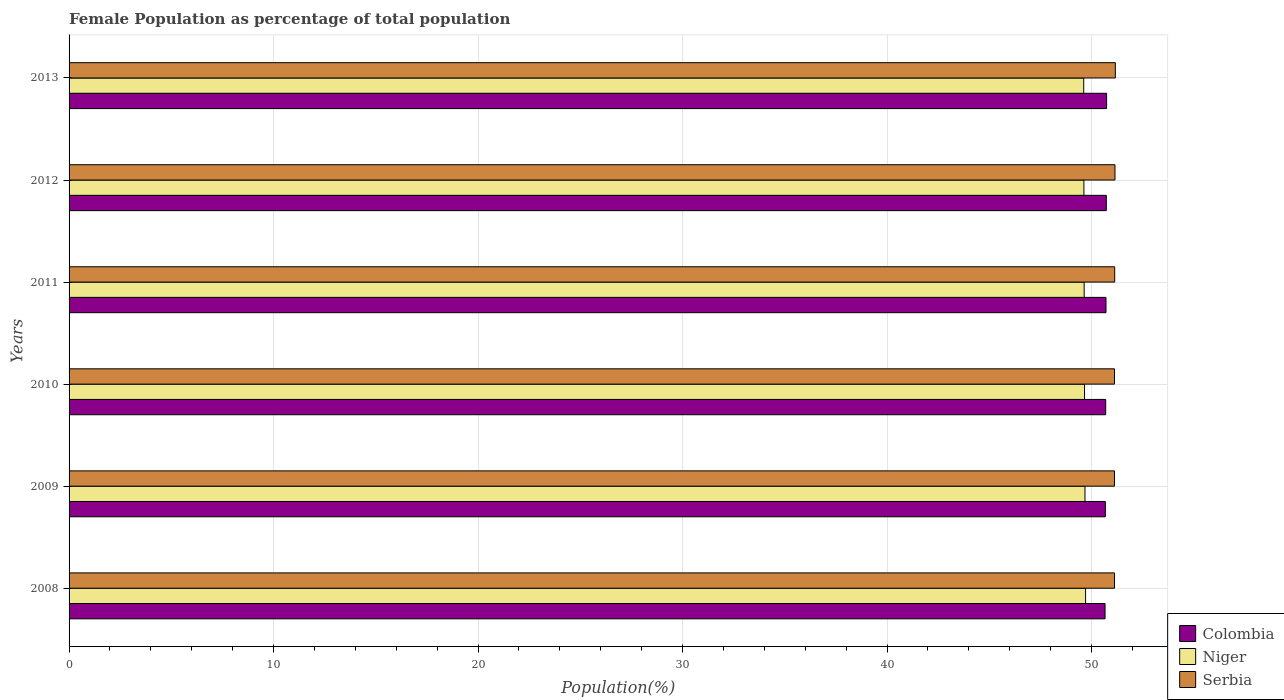How many different coloured bars are there?
Keep it short and to the point. 3. Are the number of bars on each tick of the Y-axis equal?
Your answer should be compact. Yes. How many bars are there on the 5th tick from the bottom?
Offer a terse response. 3. What is the label of the 5th group of bars from the top?
Your answer should be compact. 2009. In how many cases, is the number of bars for a given year not equal to the number of legend labels?
Offer a very short reply. 0. What is the female population in in Colombia in 2008?
Make the answer very short. 50.66. Across all years, what is the maximum female population in in Colombia?
Your response must be concise. 50.74. Across all years, what is the minimum female population in in Serbia?
Offer a very short reply. 51.12. What is the total female population in in Niger in the graph?
Provide a succinct answer. 297.94. What is the difference between the female population in in Colombia in 2008 and that in 2012?
Your answer should be compact. -0.06. What is the difference between the female population in in Niger in 2008 and the female population in in Serbia in 2012?
Make the answer very short. -1.44. What is the average female population in in Colombia per year?
Your answer should be compact. 50.7. In the year 2011, what is the difference between the female population in in Serbia and female population in in Colombia?
Your response must be concise. 0.42. What is the ratio of the female population in in Serbia in 2010 to that in 2013?
Your answer should be compact. 1. Is the female population in in Serbia in 2009 less than that in 2013?
Your answer should be compact. Yes. What is the difference between the highest and the second highest female population in in Colombia?
Provide a succinct answer. 0.02. What is the difference between the highest and the lowest female population in in Niger?
Provide a succinct answer. 0.09. What does the 1st bar from the top in 2008 represents?
Your response must be concise. Serbia. How many bars are there?
Your answer should be compact. 18. What is the difference between two consecutive major ticks on the X-axis?
Give a very brief answer. 10. Are the values on the major ticks of X-axis written in scientific E-notation?
Provide a succinct answer. No. Does the graph contain any zero values?
Ensure brevity in your answer.  No. Does the graph contain grids?
Provide a short and direct response. Yes. How many legend labels are there?
Offer a terse response. 3. How are the legend labels stacked?
Your response must be concise. Vertical. What is the title of the graph?
Give a very brief answer. Female Population as percentage of total population. What is the label or title of the X-axis?
Your response must be concise. Population(%). What is the Population(%) in Colombia in 2008?
Give a very brief answer. 50.66. What is the Population(%) of Niger in 2008?
Give a very brief answer. 49.71. What is the Population(%) in Serbia in 2008?
Your response must be concise. 51.13. What is the Population(%) of Colombia in 2009?
Your answer should be very brief. 50.68. What is the Population(%) of Niger in 2009?
Ensure brevity in your answer.  49.68. What is the Population(%) in Serbia in 2009?
Give a very brief answer. 51.12. What is the Population(%) in Colombia in 2010?
Provide a short and direct response. 50.69. What is the Population(%) of Niger in 2010?
Give a very brief answer. 49.66. What is the Population(%) in Serbia in 2010?
Offer a very short reply. 51.12. What is the Population(%) in Colombia in 2011?
Provide a short and direct response. 50.71. What is the Population(%) of Niger in 2011?
Provide a short and direct response. 49.64. What is the Population(%) of Serbia in 2011?
Offer a very short reply. 51.13. What is the Population(%) in Colombia in 2012?
Your answer should be very brief. 50.72. What is the Population(%) of Niger in 2012?
Make the answer very short. 49.63. What is the Population(%) in Serbia in 2012?
Ensure brevity in your answer.  51.15. What is the Population(%) of Colombia in 2013?
Offer a very short reply. 50.74. What is the Population(%) of Niger in 2013?
Offer a terse response. 49.62. What is the Population(%) in Serbia in 2013?
Offer a terse response. 51.16. Across all years, what is the maximum Population(%) of Colombia?
Provide a succinct answer. 50.74. Across all years, what is the maximum Population(%) in Niger?
Your answer should be very brief. 49.71. Across all years, what is the maximum Population(%) in Serbia?
Your answer should be very brief. 51.16. Across all years, what is the minimum Population(%) in Colombia?
Your answer should be very brief. 50.66. Across all years, what is the minimum Population(%) of Niger?
Provide a short and direct response. 49.62. Across all years, what is the minimum Population(%) in Serbia?
Give a very brief answer. 51.12. What is the total Population(%) of Colombia in the graph?
Keep it short and to the point. 304.2. What is the total Population(%) of Niger in the graph?
Offer a terse response. 297.94. What is the total Population(%) in Serbia in the graph?
Ensure brevity in your answer.  306.82. What is the difference between the Population(%) of Colombia in 2008 and that in 2009?
Your answer should be compact. -0.02. What is the difference between the Population(%) in Niger in 2008 and that in 2009?
Your answer should be very brief. 0.03. What is the difference between the Population(%) of Serbia in 2008 and that in 2009?
Provide a succinct answer. 0. What is the difference between the Population(%) of Colombia in 2008 and that in 2010?
Make the answer very short. -0.03. What is the difference between the Population(%) in Niger in 2008 and that in 2010?
Make the answer very short. 0.05. What is the difference between the Population(%) of Serbia in 2008 and that in 2010?
Offer a very short reply. 0. What is the difference between the Population(%) of Colombia in 2008 and that in 2011?
Your answer should be very brief. -0.05. What is the difference between the Population(%) of Niger in 2008 and that in 2011?
Your answer should be compact. 0.07. What is the difference between the Population(%) in Serbia in 2008 and that in 2011?
Your answer should be compact. -0.01. What is the difference between the Population(%) of Colombia in 2008 and that in 2012?
Offer a terse response. -0.06. What is the difference between the Population(%) of Niger in 2008 and that in 2012?
Offer a terse response. 0.08. What is the difference between the Population(%) in Serbia in 2008 and that in 2012?
Keep it short and to the point. -0.02. What is the difference between the Population(%) in Colombia in 2008 and that in 2013?
Your answer should be very brief. -0.08. What is the difference between the Population(%) in Niger in 2008 and that in 2013?
Provide a succinct answer. 0.09. What is the difference between the Population(%) of Serbia in 2008 and that in 2013?
Provide a short and direct response. -0.04. What is the difference between the Population(%) of Colombia in 2009 and that in 2010?
Provide a short and direct response. -0.02. What is the difference between the Population(%) of Niger in 2009 and that in 2010?
Make the answer very short. 0.02. What is the difference between the Population(%) of Serbia in 2009 and that in 2010?
Provide a succinct answer. -0. What is the difference between the Population(%) of Colombia in 2009 and that in 2011?
Your answer should be compact. -0.03. What is the difference between the Population(%) in Niger in 2009 and that in 2011?
Make the answer very short. 0.04. What is the difference between the Population(%) of Serbia in 2009 and that in 2011?
Keep it short and to the point. -0.01. What is the difference between the Population(%) of Colombia in 2009 and that in 2012?
Your response must be concise. -0.05. What is the difference between the Population(%) of Niger in 2009 and that in 2012?
Provide a short and direct response. 0.05. What is the difference between the Population(%) of Serbia in 2009 and that in 2012?
Your answer should be very brief. -0.02. What is the difference between the Population(%) in Colombia in 2009 and that in 2013?
Your answer should be very brief. -0.06. What is the difference between the Population(%) of Niger in 2009 and that in 2013?
Offer a very short reply. 0.06. What is the difference between the Population(%) in Serbia in 2009 and that in 2013?
Offer a very short reply. -0.04. What is the difference between the Population(%) in Colombia in 2010 and that in 2011?
Provide a short and direct response. -0.02. What is the difference between the Population(%) of Niger in 2010 and that in 2011?
Your answer should be very brief. 0.02. What is the difference between the Population(%) in Serbia in 2010 and that in 2011?
Provide a short and direct response. -0.01. What is the difference between the Population(%) of Colombia in 2010 and that in 2012?
Your answer should be compact. -0.03. What is the difference between the Population(%) of Niger in 2010 and that in 2012?
Provide a short and direct response. 0.03. What is the difference between the Population(%) in Serbia in 2010 and that in 2012?
Offer a very short reply. -0.02. What is the difference between the Population(%) of Colombia in 2010 and that in 2013?
Make the answer very short. -0.05. What is the difference between the Population(%) in Niger in 2010 and that in 2013?
Keep it short and to the point. 0.04. What is the difference between the Population(%) in Serbia in 2010 and that in 2013?
Give a very brief answer. -0.04. What is the difference between the Population(%) in Colombia in 2011 and that in 2012?
Your response must be concise. -0.02. What is the difference between the Population(%) of Niger in 2011 and that in 2012?
Provide a short and direct response. 0.01. What is the difference between the Population(%) of Serbia in 2011 and that in 2012?
Ensure brevity in your answer.  -0.01. What is the difference between the Population(%) of Colombia in 2011 and that in 2013?
Your answer should be very brief. -0.03. What is the difference between the Population(%) of Niger in 2011 and that in 2013?
Offer a terse response. 0.02. What is the difference between the Population(%) of Serbia in 2011 and that in 2013?
Provide a short and direct response. -0.03. What is the difference between the Population(%) in Colombia in 2012 and that in 2013?
Keep it short and to the point. -0.02. What is the difference between the Population(%) in Niger in 2012 and that in 2013?
Give a very brief answer. 0.01. What is the difference between the Population(%) of Serbia in 2012 and that in 2013?
Your answer should be compact. -0.02. What is the difference between the Population(%) of Colombia in 2008 and the Population(%) of Niger in 2009?
Give a very brief answer. 0.98. What is the difference between the Population(%) of Colombia in 2008 and the Population(%) of Serbia in 2009?
Keep it short and to the point. -0.46. What is the difference between the Population(%) of Niger in 2008 and the Population(%) of Serbia in 2009?
Offer a very short reply. -1.41. What is the difference between the Population(%) in Colombia in 2008 and the Population(%) in Niger in 2010?
Offer a terse response. 1. What is the difference between the Population(%) of Colombia in 2008 and the Population(%) of Serbia in 2010?
Your answer should be very brief. -0.46. What is the difference between the Population(%) in Niger in 2008 and the Population(%) in Serbia in 2010?
Offer a very short reply. -1.41. What is the difference between the Population(%) of Colombia in 2008 and the Population(%) of Niger in 2011?
Your answer should be compact. 1.02. What is the difference between the Population(%) of Colombia in 2008 and the Population(%) of Serbia in 2011?
Provide a short and direct response. -0.47. What is the difference between the Population(%) in Niger in 2008 and the Population(%) in Serbia in 2011?
Keep it short and to the point. -1.42. What is the difference between the Population(%) of Colombia in 2008 and the Population(%) of Niger in 2012?
Offer a terse response. 1.03. What is the difference between the Population(%) of Colombia in 2008 and the Population(%) of Serbia in 2012?
Offer a very short reply. -0.49. What is the difference between the Population(%) of Niger in 2008 and the Population(%) of Serbia in 2012?
Provide a succinct answer. -1.44. What is the difference between the Population(%) of Colombia in 2008 and the Population(%) of Niger in 2013?
Ensure brevity in your answer.  1.04. What is the difference between the Population(%) in Colombia in 2008 and the Population(%) in Serbia in 2013?
Give a very brief answer. -0.5. What is the difference between the Population(%) of Niger in 2008 and the Population(%) of Serbia in 2013?
Provide a short and direct response. -1.46. What is the difference between the Population(%) in Colombia in 2009 and the Population(%) in Niger in 2010?
Provide a succinct answer. 1.02. What is the difference between the Population(%) in Colombia in 2009 and the Population(%) in Serbia in 2010?
Your answer should be compact. -0.45. What is the difference between the Population(%) in Niger in 2009 and the Population(%) in Serbia in 2010?
Offer a terse response. -1.44. What is the difference between the Population(%) in Colombia in 2009 and the Population(%) in Niger in 2011?
Give a very brief answer. 1.04. What is the difference between the Population(%) of Colombia in 2009 and the Population(%) of Serbia in 2011?
Provide a short and direct response. -0.46. What is the difference between the Population(%) in Niger in 2009 and the Population(%) in Serbia in 2011?
Make the answer very short. -1.45. What is the difference between the Population(%) in Colombia in 2009 and the Population(%) in Niger in 2012?
Give a very brief answer. 1.05. What is the difference between the Population(%) of Colombia in 2009 and the Population(%) of Serbia in 2012?
Your response must be concise. -0.47. What is the difference between the Population(%) in Niger in 2009 and the Population(%) in Serbia in 2012?
Make the answer very short. -1.47. What is the difference between the Population(%) of Colombia in 2009 and the Population(%) of Niger in 2013?
Offer a very short reply. 1.06. What is the difference between the Population(%) of Colombia in 2009 and the Population(%) of Serbia in 2013?
Ensure brevity in your answer.  -0.49. What is the difference between the Population(%) in Niger in 2009 and the Population(%) in Serbia in 2013?
Your answer should be very brief. -1.48. What is the difference between the Population(%) of Colombia in 2010 and the Population(%) of Niger in 2011?
Provide a succinct answer. 1.05. What is the difference between the Population(%) of Colombia in 2010 and the Population(%) of Serbia in 2011?
Provide a succinct answer. -0.44. What is the difference between the Population(%) in Niger in 2010 and the Population(%) in Serbia in 2011?
Give a very brief answer. -1.47. What is the difference between the Population(%) in Colombia in 2010 and the Population(%) in Niger in 2012?
Keep it short and to the point. 1.06. What is the difference between the Population(%) in Colombia in 2010 and the Population(%) in Serbia in 2012?
Your answer should be very brief. -0.45. What is the difference between the Population(%) of Niger in 2010 and the Population(%) of Serbia in 2012?
Your answer should be very brief. -1.49. What is the difference between the Population(%) in Colombia in 2010 and the Population(%) in Niger in 2013?
Make the answer very short. 1.07. What is the difference between the Population(%) of Colombia in 2010 and the Population(%) of Serbia in 2013?
Provide a succinct answer. -0.47. What is the difference between the Population(%) of Niger in 2010 and the Population(%) of Serbia in 2013?
Ensure brevity in your answer.  -1.51. What is the difference between the Population(%) in Colombia in 2011 and the Population(%) in Niger in 2012?
Your answer should be very brief. 1.08. What is the difference between the Population(%) in Colombia in 2011 and the Population(%) in Serbia in 2012?
Offer a terse response. -0.44. What is the difference between the Population(%) in Niger in 2011 and the Population(%) in Serbia in 2012?
Your answer should be very brief. -1.51. What is the difference between the Population(%) in Colombia in 2011 and the Population(%) in Niger in 2013?
Provide a succinct answer. 1.09. What is the difference between the Population(%) of Colombia in 2011 and the Population(%) of Serbia in 2013?
Your response must be concise. -0.46. What is the difference between the Population(%) in Niger in 2011 and the Population(%) in Serbia in 2013?
Your response must be concise. -1.52. What is the difference between the Population(%) of Colombia in 2012 and the Population(%) of Niger in 2013?
Provide a short and direct response. 1.1. What is the difference between the Population(%) in Colombia in 2012 and the Population(%) in Serbia in 2013?
Your answer should be very brief. -0.44. What is the difference between the Population(%) of Niger in 2012 and the Population(%) of Serbia in 2013?
Offer a terse response. -1.54. What is the average Population(%) in Colombia per year?
Make the answer very short. 50.7. What is the average Population(%) in Niger per year?
Provide a succinct answer. 49.66. What is the average Population(%) in Serbia per year?
Your answer should be compact. 51.14. In the year 2008, what is the difference between the Population(%) in Colombia and Population(%) in Niger?
Make the answer very short. 0.95. In the year 2008, what is the difference between the Population(%) of Colombia and Population(%) of Serbia?
Provide a short and direct response. -0.46. In the year 2008, what is the difference between the Population(%) in Niger and Population(%) in Serbia?
Your answer should be very brief. -1.42. In the year 2009, what is the difference between the Population(%) in Colombia and Population(%) in Niger?
Your answer should be very brief. 1. In the year 2009, what is the difference between the Population(%) of Colombia and Population(%) of Serbia?
Your response must be concise. -0.45. In the year 2009, what is the difference between the Population(%) in Niger and Population(%) in Serbia?
Ensure brevity in your answer.  -1.44. In the year 2010, what is the difference between the Population(%) in Colombia and Population(%) in Niger?
Offer a terse response. 1.03. In the year 2010, what is the difference between the Population(%) of Colombia and Population(%) of Serbia?
Make the answer very short. -0.43. In the year 2010, what is the difference between the Population(%) of Niger and Population(%) of Serbia?
Your response must be concise. -1.47. In the year 2011, what is the difference between the Population(%) in Colombia and Population(%) in Niger?
Your answer should be very brief. 1.07. In the year 2011, what is the difference between the Population(%) of Colombia and Population(%) of Serbia?
Your answer should be compact. -0.42. In the year 2011, what is the difference between the Population(%) of Niger and Population(%) of Serbia?
Make the answer very short. -1.49. In the year 2012, what is the difference between the Population(%) in Colombia and Population(%) in Niger?
Your answer should be very brief. 1.09. In the year 2012, what is the difference between the Population(%) in Colombia and Population(%) in Serbia?
Your answer should be compact. -0.42. In the year 2012, what is the difference between the Population(%) in Niger and Population(%) in Serbia?
Your answer should be compact. -1.52. In the year 2013, what is the difference between the Population(%) in Colombia and Population(%) in Niger?
Provide a short and direct response. 1.12. In the year 2013, what is the difference between the Population(%) in Colombia and Population(%) in Serbia?
Your answer should be compact. -0.43. In the year 2013, what is the difference between the Population(%) of Niger and Population(%) of Serbia?
Keep it short and to the point. -1.55. What is the ratio of the Population(%) of Colombia in 2008 to that in 2012?
Offer a terse response. 1. What is the ratio of the Population(%) of Serbia in 2008 to that in 2013?
Ensure brevity in your answer.  1. What is the ratio of the Population(%) in Colombia in 2009 to that in 2010?
Ensure brevity in your answer.  1. What is the ratio of the Population(%) of Niger in 2009 to that in 2010?
Your answer should be very brief. 1. What is the ratio of the Population(%) in Colombia in 2009 to that in 2011?
Provide a short and direct response. 1. What is the ratio of the Population(%) of Niger in 2009 to that in 2011?
Keep it short and to the point. 1. What is the ratio of the Population(%) in Serbia in 2009 to that in 2011?
Your response must be concise. 1. What is the ratio of the Population(%) of Serbia in 2009 to that in 2012?
Your answer should be compact. 1. What is the ratio of the Population(%) of Serbia in 2009 to that in 2013?
Keep it short and to the point. 1. What is the ratio of the Population(%) in Colombia in 2010 to that in 2011?
Your response must be concise. 1. What is the ratio of the Population(%) in Niger in 2010 to that in 2011?
Your response must be concise. 1. What is the ratio of the Population(%) in Serbia in 2010 to that in 2012?
Your answer should be very brief. 1. What is the ratio of the Population(%) of Colombia in 2010 to that in 2013?
Keep it short and to the point. 1. What is the ratio of the Population(%) in Niger in 2011 to that in 2012?
Provide a succinct answer. 1. What is the ratio of the Population(%) in Serbia in 2011 to that in 2013?
Your response must be concise. 1. What is the ratio of the Population(%) of Niger in 2012 to that in 2013?
Keep it short and to the point. 1. What is the difference between the highest and the second highest Population(%) of Colombia?
Provide a succinct answer. 0.02. What is the difference between the highest and the second highest Population(%) in Niger?
Offer a very short reply. 0.03. What is the difference between the highest and the second highest Population(%) in Serbia?
Offer a terse response. 0.02. What is the difference between the highest and the lowest Population(%) in Colombia?
Provide a short and direct response. 0.08. What is the difference between the highest and the lowest Population(%) of Niger?
Your answer should be compact. 0.09. What is the difference between the highest and the lowest Population(%) of Serbia?
Provide a short and direct response. 0.04. 